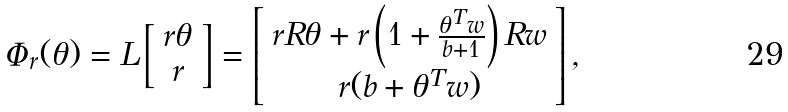<formula> <loc_0><loc_0><loc_500><loc_500>\Phi _ { r } ( \theta ) = L \left [ \begin{array} { c } r \theta \\ r \end{array} \right ] = \left [ \begin{array} { c } r R \theta + r \left ( 1 + \frac { \theta ^ { T } w } { b + 1 } \right ) R w \\ r ( b + \theta ^ { T } w ) \end{array} \right ] ,</formula> 